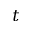<formula> <loc_0><loc_0><loc_500><loc_500>t</formula> 